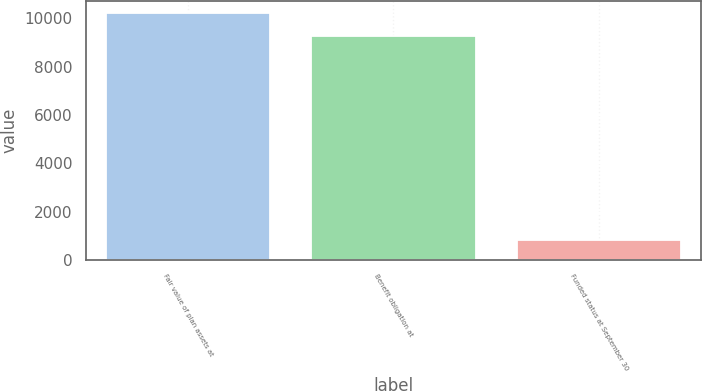Convert chart to OTSL. <chart><loc_0><loc_0><loc_500><loc_500><bar_chart><fcel>Fair value of plan assets at<fcel>Benefit obligation at<fcel>Funded status at September 30<nl><fcel>10208<fcel>9280<fcel>814<nl></chart> 